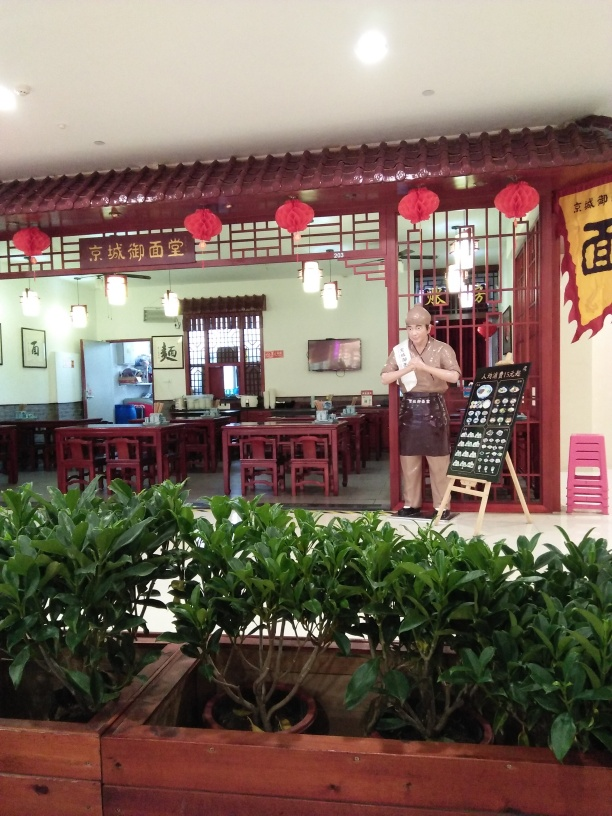What kind of food do you think this shop specializes in? Given the traditional Chinese decor and the appearance of the menu board, it seems this shop likely specializes in authentic Chinese cuisine. The presence of tea canisters on the shelf also suggests a variety of teas might be available. 